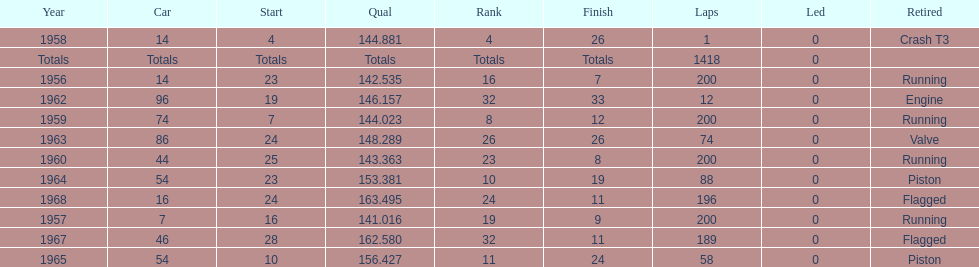What was its best starting position? 4. 